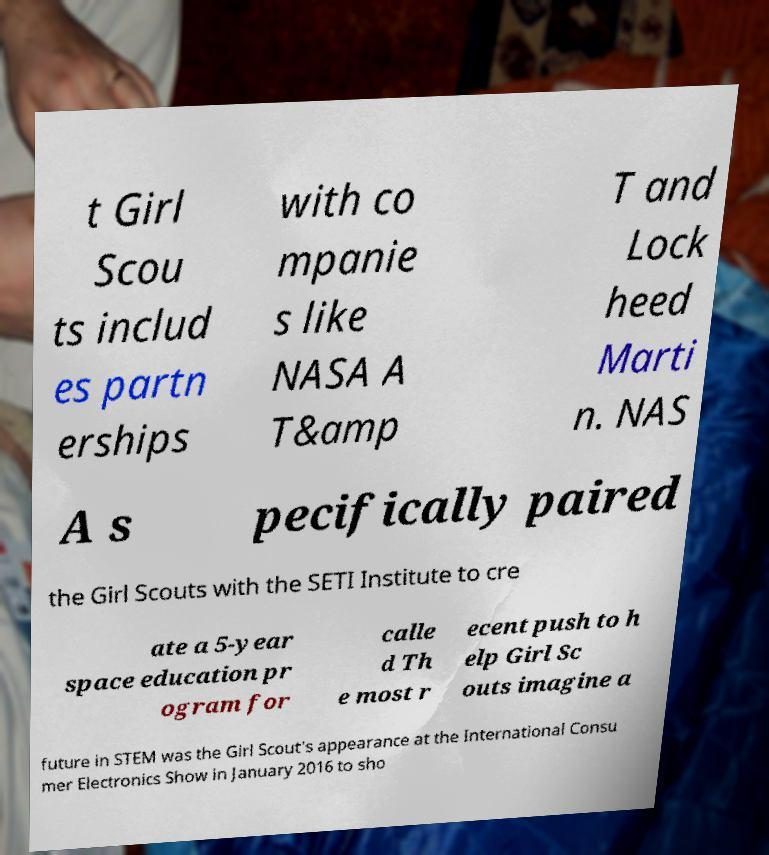For documentation purposes, I need the text within this image transcribed. Could you provide that? t Girl Scou ts includ es partn erships with co mpanie s like NASA A T&amp T and Lock heed Marti n. NAS A s pecifically paired the Girl Scouts with the SETI Institute to cre ate a 5-year space education pr ogram for calle d Th e most r ecent push to h elp Girl Sc outs imagine a future in STEM was the Girl Scout's appearance at the International Consu mer Electronics Show in January 2016 to sho 